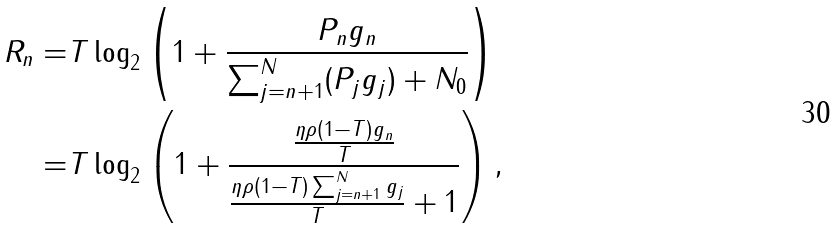Convert formula to latex. <formula><loc_0><loc_0><loc_500><loc_500>R _ { n } = & T \log _ { 2 } \left ( 1 + \frac { P _ { n } g _ { n } } { \sum _ { j = n + 1 } ^ { N } ( P _ { j } g _ { j } ) + N _ { 0 } } \right ) \\ = & T \log _ { 2 } \left ( 1 + \frac { \frac { \eta \rho ( 1 - T ) g _ { n } } { T } } { \frac { \eta \rho ( 1 - T ) \sum _ { j = n + 1 } ^ { N } g _ { j } } { T } + 1 } \right ) ,</formula> 